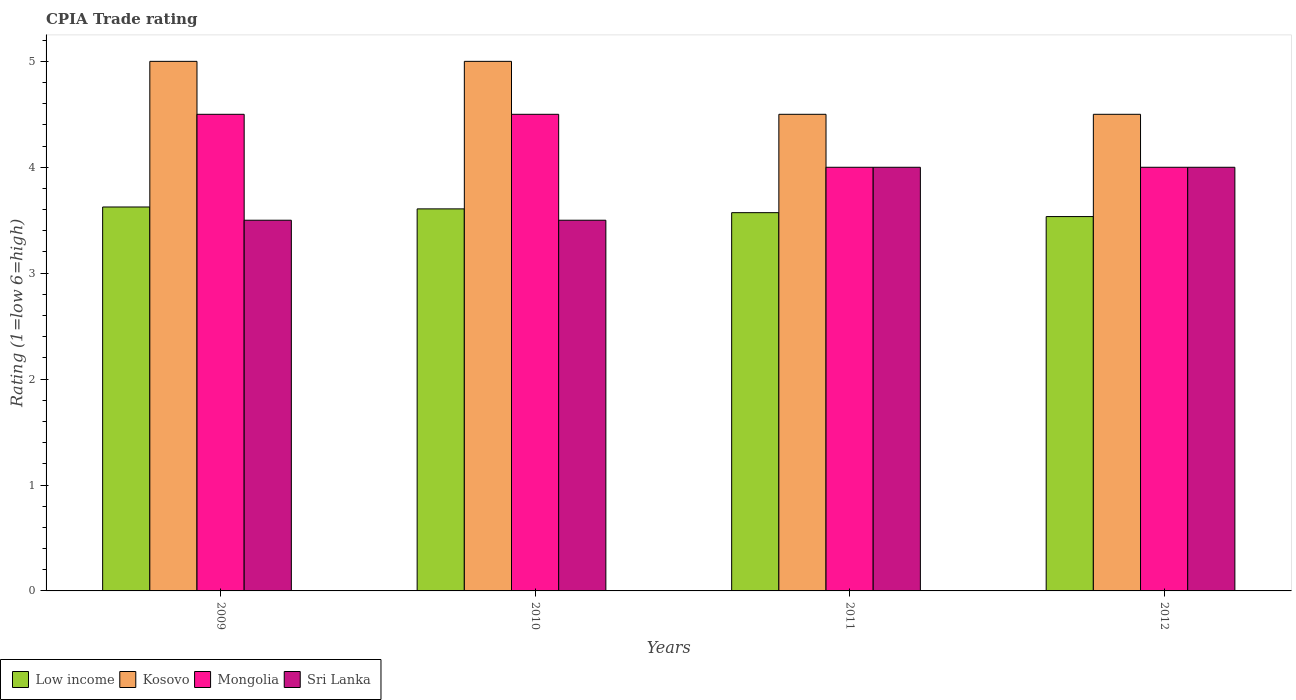How many groups of bars are there?
Offer a terse response. 4. Are the number of bars on each tick of the X-axis equal?
Offer a terse response. Yes. How many bars are there on the 3rd tick from the left?
Make the answer very short. 4. What is the label of the 1st group of bars from the left?
Keep it short and to the point. 2009. What is the CPIA rating in Low income in 2011?
Offer a very short reply. 3.57. In which year was the CPIA rating in Mongolia maximum?
Ensure brevity in your answer.  2009. What is the total CPIA rating in Kosovo in the graph?
Provide a short and direct response. 19. What is the difference between the CPIA rating in Low income in 2009 and that in 2010?
Provide a succinct answer. 0.02. What is the average CPIA rating in Sri Lanka per year?
Keep it short and to the point. 3.75. In the year 2010, what is the difference between the CPIA rating in Sri Lanka and CPIA rating in Mongolia?
Your response must be concise. -1. In how many years, is the CPIA rating in Low income greater than 2?
Your response must be concise. 4. What is the ratio of the CPIA rating in Low income in 2009 to that in 2012?
Your answer should be compact. 1.03. In how many years, is the CPIA rating in Kosovo greater than the average CPIA rating in Kosovo taken over all years?
Your answer should be very brief. 2. Is it the case that in every year, the sum of the CPIA rating in Kosovo and CPIA rating in Low income is greater than the sum of CPIA rating in Sri Lanka and CPIA rating in Mongolia?
Provide a short and direct response. No. What does the 2nd bar from the left in 2012 represents?
Your answer should be compact. Kosovo. Is it the case that in every year, the sum of the CPIA rating in Kosovo and CPIA rating in Sri Lanka is greater than the CPIA rating in Mongolia?
Offer a terse response. Yes. Are all the bars in the graph horizontal?
Ensure brevity in your answer.  No. How many years are there in the graph?
Your response must be concise. 4. What is the difference between two consecutive major ticks on the Y-axis?
Ensure brevity in your answer.  1. Does the graph contain grids?
Offer a terse response. No. Where does the legend appear in the graph?
Give a very brief answer. Bottom left. How many legend labels are there?
Provide a short and direct response. 4. How are the legend labels stacked?
Offer a very short reply. Horizontal. What is the title of the graph?
Give a very brief answer. CPIA Trade rating. Does "United Kingdom" appear as one of the legend labels in the graph?
Your answer should be very brief. No. What is the label or title of the X-axis?
Your answer should be compact. Years. What is the Rating (1=low 6=high) of Low income in 2009?
Offer a very short reply. 3.62. What is the Rating (1=low 6=high) of Low income in 2010?
Provide a succinct answer. 3.61. What is the Rating (1=low 6=high) in Mongolia in 2010?
Offer a very short reply. 4.5. What is the Rating (1=low 6=high) in Sri Lanka in 2010?
Offer a terse response. 3.5. What is the Rating (1=low 6=high) of Low income in 2011?
Offer a terse response. 3.57. What is the Rating (1=low 6=high) in Sri Lanka in 2011?
Offer a terse response. 4. What is the Rating (1=low 6=high) of Low income in 2012?
Provide a succinct answer. 3.53. What is the Rating (1=low 6=high) in Kosovo in 2012?
Offer a very short reply. 4.5. What is the Rating (1=low 6=high) of Mongolia in 2012?
Ensure brevity in your answer.  4. What is the Rating (1=low 6=high) in Sri Lanka in 2012?
Ensure brevity in your answer.  4. Across all years, what is the maximum Rating (1=low 6=high) of Low income?
Your answer should be very brief. 3.62. Across all years, what is the maximum Rating (1=low 6=high) of Mongolia?
Ensure brevity in your answer.  4.5. Across all years, what is the maximum Rating (1=low 6=high) of Sri Lanka?
Your answer should be compact. 4. Across all years, what is the minimum Rating (1=low 6=high) in Low income?
Provide a succinct answer. 3.53. What is the total Rating (1=low 6=high) of Low income in the graph?
Your answer should be compact. 14.34. What is the total Rating (1=low 6=high) in Kosovo in the graph?
Your answer should be very brief. 19. What is the difference between the Rating (1=low 6=high) in Low income in 2009 and that in 2010?
Keep it short and to the point. 0.02. What is the difference between the Rating (1=low 6=high) in Mongolia in 2009 and that in 2010?
Make the answer very short. 0. What is the difference between the Rating (1=low 6=high) of Sri Lanka in 2009 and that in 2010?
Ensure brevity in your answer.  0. What is the difference between the Rating (1=low 6=high) in Low income in 2009 and that in 2011?
Provide a short and direct response. 0.05. What is the difference between the Rating (1=low 6=high) in Kosovo in 2009 and that in 2011?
Provide a short and direct response. 0.5. What is the difference between the Rating (1=low 6=high) of Sri Lanka in 2009 and that in 2011?
Your answer should be very brief. -0.5. What is the difference between the Rating (1=low 6=high) of Low income in 2009 and that in 2012?
Your response must be concise. 0.09. What is the difference between the Rating (1=low 6=high) in Low income in 2010 and that in 2011?
Give a very brief answer. 0.04. What is the difference between the Rating (1=low 6=high) of Mongolia in 2010 and that in 2011?
Provide a succinct answer. 0.5. What is the difference between the Rating (1=low 6=high) of Low income in 2010 and that in 2012?
Offer a very short reply. 0.07. What is the difference between the Rating (1=low 6=high) in Sri Lanka in 2010 and that in 2012?
Your response must be concise. -0.5. What is the difference between the Rating (1=low 6=high) of Low income in 2011 and that in 2012?
Make the answer very short. 0.04. What is the difference between the Rating (1=low 6=high) in Kosovo in 2011 and that in 2012?
Ensure brevity in your answer.  0. What is the difference between the Rating (1=low 6=high) of Low income in 2009 and the Rating (1=low 6=high) of Kosovo in 2010?
Give a very brief answer. -1.38. What is the difference between the Rating (1=low 6=high) of Low income in 2009 and the Rating (1=low 6=high) of Mongolia in 2010?
Give a very brief answer. -0.88. What is the difference between the Rating (1=low 6=high) of Kosovo in 2009 and the Rating (1=low 6=high) of Sri Lanka in 2010?
Make the answer very short. 1.5. What is the difference between the Rating (1=low 6=high) in Mongolia in 2009 and the Rating (1=low 6=high) in Sri Lanka in 2010?
Your response must be concise. 1. What is the difference between the Rating (1=low 6=high) of Low income in 2009 and the Rating (1=low 6=high) of Kosovo in 2011?
Make the answer very short. -0.88. What is the difference between the Rating (1=low 6=high) of Low income in 2009 and the Rating (1=low 6=high) of Mongolia in 2011?
Your answer should be compact. -0.38. What is the difference between the Rating (1=low 6=high) in Low income in 2009 and the Rating (1=low 6=high) in Sri Lanka in 2011?
Your answer should be compact. -0.38. What is the difference between the Rating (1=low 6=high) in Kosovo in 2009 and the Rating (1=low 6=high) in Mongolia in 2011?
Keep it short and to the point. 1. What is the difference between the Rating (1=low 6=high) in Kosovo in 2009 and the Rating (1=low 6=high) in Sri Lanka in 2011?
Offer a very short reply. 1. What is the difference between the Rating (1=low 6=high) of Low income in 2009 and the Rating (1=low 6=high) of Kosovo in 2012?
Your answer should be very brief. -0.88. What is the difference between the Rating (1=low 6=high) in Low income in 2009 and the Rating (1=low 6=high) in Mongolia in 2012?
Offer a terse response. -0.38. What is the difference between the Rating (1=low 6=high) of Low income in 2009 and the Rating (1=low 6=high) of Sri Lanka in 2012?
Offer a very short reply. -0.38. What is the difference between the Rating (1=low 6=high) in Kosovo in 2009 and the Rating (1=low 6=high) in Mongolia in 2012?
Offer a very short reply. 1. What is the difference between the Rating (1=low 6=high) of Low income in 2010 and the Rating (1=low 6=high) of Kosovo in 2011?
Keep it short and to the point. -0.89. What is the difference between the Rating (1=low 6=high) of Low income in 2010 and the Rating (1=low 6=high) of Mongolia in 2011?
Provide a short and direct response. -0.39. What is the difference between the Rating (1=low 6=high) of Low income in 2010 and the Rating (1=low 6=high) of Sri Lanka in 2011?
Your response must be concise. -0.39. What is the difference between the Rating (1=low 6=high) of Mongolia in 2010 and the Rating (1=low 6=high) of Sri Lanka in 2011?
Give a very brief answer. 0.5. What is the difference between the Rating (1=low 6=high) of Low income in 2010 and the Rating (1=low 6=high) of Kosovo in 2012?
Your answer should be compact. -0.89. What is the difference between the Rating (1=low 6=high) in Low income in 2010 and the Rating (1=low 6=high) in Mongolia in 2012?
Provide a short and direct response. -0.39. What is the difference between the Rating (1=low 6=high) of Low income in 2010 and the Rating (1=low 6=high) of Sri Lanka in 2012?
Your response must be concise. -0.39. What is the difference between the Rating (1=low 6=high) in Kosovo in 2010 and the Rating (1=low 6=high) in Mongolia in 2012?
Your answer should be compact. 1. What is the difference between the Rating (1=low 6=high) in Kosovo in 2010 and the Rating (1=low 6=high) in Sri Lanka in 2012?
Make the answer very short. 1. What is the difference between the Rating (1=low 6=high) of Mongolia in 2010 and the Rating (1=low 6=high) of Sri Lanka in 2012?
Give a very brief answer. 0.5. What is the difference between the Rating (1=low 6=high) in Low income in 2011 and the Rating (1=low 6=high) in Kosovo in 2012?
Provide a succinct answer. -0.93. What is the difference between the Rating (1=low 6=high) of Low income in 2011 and the Rating (1=low 6=high) of Mongolia in 2012?
Your response must be concise. -0.43. What is the difference between the Rating (1=low 6=high) of Low income in 2011 and the Rating (1=low 6=high) of Sri Lanka in 2012?
Ensure brevity in your answer.  -0.43. What is the difference between the Rating (1=low 6=high) of Kosovo in 2011 and the Rating (1=low 6=high) of Sri Lanka in 2012?
Offer a very short reply. 0.5. What is the average Rating (1=low 6=high) of Low income per year?
Your response must be concise. 3.58. What is the average Rating (1=low 6=high) in Kosovo per year?
Ensure brevity in your answer.  4.75. What is the average Rating (1=low 6=high) in Mongolia per year?
Provide a succinct answer. 4.25. What is the average Rating (1=low 6=high) of Sri Lanka per year?
Keep it short and to the point. 3.75. In the year 2009, what is the difference between the Rating (1=low 6=high) of Low income and Rating (1=low 6=high) of Kosovo?
Your response must be concise. -1.38. In the year 2009, what is the difference between the Rating (1=low 6=high) in Low income and Rating (1=low 6=high) in Mongolia?
Keep it short and to the point. -0.88. In the year 2009, what is the difference between the Rating (1=low 6=high) in Low income and Rating (1=low 6=high) in Sri Lanka?
Provide a short and direct response. 0.12. In the year 2009, what is the difference between the Rating (1=low 6=high) of Kosovo and Rating (1=low 6=high) of Mongolia?
Provide a short and direct response. 0.5. In the year 2009, what is the difference between the Rating (1=low 6=high) of Kosovo and Rating (1=low 6=high) of Sri Lanka?
Your answer should be very brief. 1.5. In the year 2010, what is the difference between the Rating (1=low 6=high) in Low income and Rating (1=low 6=high) in Kosovo?
Make the answer very short. -1.39. In the year 2010, what is the difference between the Rating (1=low 6=high) in Low income and Rating (1=low 6=high) in Mongolia?
Make the answer very short. -0.89. In the year 2010, what is the difference between the Rating (1=low 6=high) of Low income and Rating (1=low 6=high) of Sri Lanka?
Your response must be concise. 0.11. In the year 2011, what is the difference between the Rating (1=low 6=high) of Low income and Rating (1=low 6=high) of Kosovo?
Keep it short and to the point. -0.93. In the year 2011, what is the difference between the Rating (1=low 6=high) in Low income and Rating (1=low 6=high) in Mongolia?
Your response must be concise. -0.43. In the year 2011, what is the difference between the Rating (1=low 6=high) of Low income and Rating (1=low 6=high) of Sri Lanka?
Give a very brief answer. -0.43. In the year 2011, what is the difference between the Rating (1=low 6=high) of Mongolia and Rating (1=low 6=high) of Sri Lanka?
Keep it short and to the point. 0. In the year 2012, what is the difference between the Rating (1=low 6=high) in Low income and Rating (1=low 6=high) in Kosovo?
Provide a succinct answer. -0.97. In the year 2012, what is the difference between the Rating (1=low 6=high) of Low income and Rating (1=low 6=high) of Mongolia?
Offer a very short reply. -0.47. In the year 2012, what is the difference between the Rating (1=low 6=high) of Low income and Rating (1=low 6=high) of Sri Lanka?
Give a very brief answer. -0.47. In the year 2012, what is the difference between the Rating (1=low 6=high) in Kosovo and Rating (1=low 6=high) in Mongolia?
Your response must be concise. 0.5. In the year 2012, what is the difference between the Rating (1=low 6=high) in Mongolia and Rating (1=low 6=high) in Sri Lanka?
Offer a very short reply. 0. What is the ratio of the Rating (1=low 6=high) of Mongolia in 2009 to that in 2010?
Give a very brief answer. 1. What is the ratio of the Rating (1=low 6=high) in Low income in 2009 to that in 2011?
Offer a very short reply. 1.01. What is the ratio of the Rating (1=low 6=high) of Mongolia in 2009 to that in 2011?
Your answer should be very brief. 1.12. What is the ratio of the Rating (1=low 6=high) of Sri Lanka in 2009 to that in 2011?
Keep it short and to the point. 0.88. What is the ratio of the Rating (1=low 6=high) in Low income in 2009 to that in 2012?
Ensure brevity in your answer.  1.03. What is the ratio of the Rating (1=low 6=high) in Mongolia in 2009 to that in 2012?
Your response must be concise. 1.12. What is the ratio of the Rating (1=low 6=high) of Low income in 2010 to that in 2011?
Provide a succinct answer. 1.01. What is the ratio of the Rating (1=low 6=high) of Sri Lanka in 2010 to that in 2011?
Your answer should be very brief. 0.88. What is the ratio of the Rating (1=low 6=high) of Low income in 2010 to that in 2012?
Offer a terse response. 1.02. What is the ratio of the Rating (1=low 6=high) of Kosovo in 2010 to that in 2012?
Offer a terse response. 1.11. What is the ratio of the Rating (1=low 6=high) of Low income in 2011 to that in 2012?
Your response must be concise. 1.01. What is the ratio of the Rating (1=low 6=high) in Mongolia in 2011 to that in 2012?
Provide a short and direct response. 1. What is the ratio of the Rating (1=low 6=high) of Sri Lanka in 2011 to that in 2012?
Offer a terse response. 1. What is the difference between the highest and the second highest Rating (1=low 6=high) of Low income?
Offer a very short reply. 0.02. What is the difference between the highest and the second highest Rating (1=low 6=high) of Kosovo?
Keep it short and to the point. 0. What is the difference between the highest and the lowest Rating (1=low 6=high) of Low income?
Your response must be concise. 0.09. What is the difference between the highest and the lowest Rating (1=low 6=high) in Mongolia?
Your response must be concise. 0.5. What is the difference between the highest and the lowest Rating (1=low 6=high) in Sri Lanka?
Your answer should be compact. 0.5. 